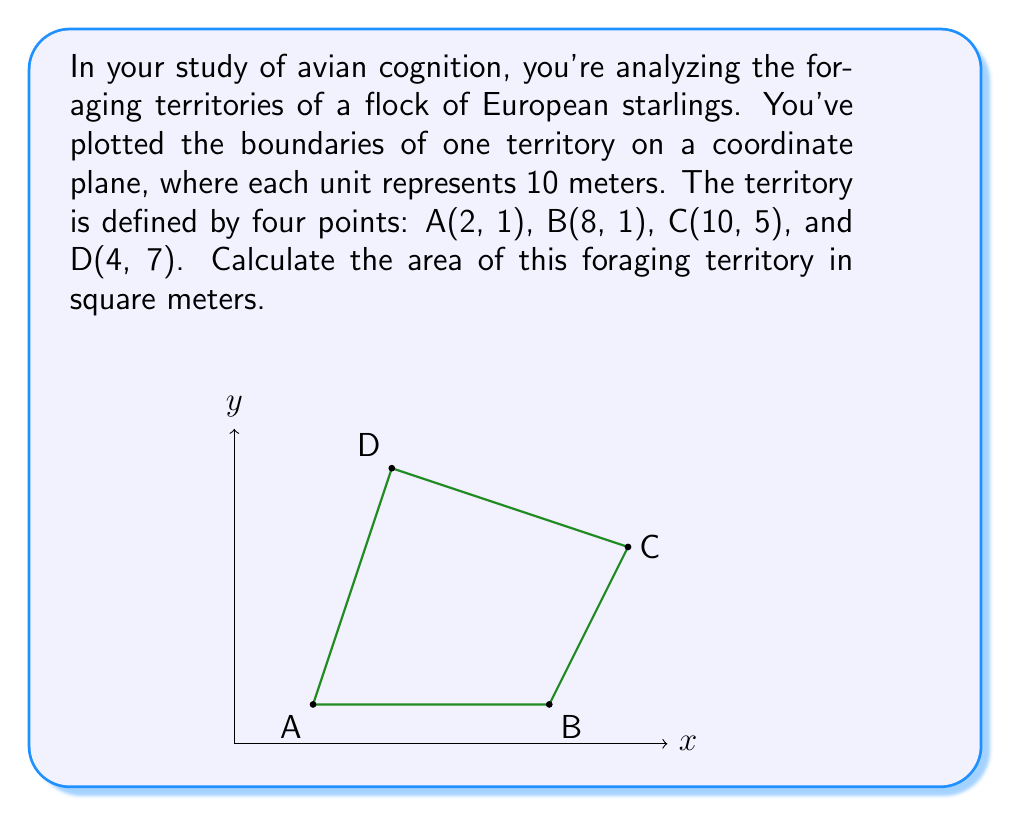Teach me how to tackle this problem. To solve this problem, we can use the shoelace formula (also known as the surveyor's formula) to calculate the area of the irregular polygon formed by the territory boundaries. The steps are as follows:

1) The shoelace formula for a quadrilateral with vertices $(x_1, y_1)$, $(x_2, y_2)$, $(x_3, y_3)$, and $(x_4, y_4)$ is:

   $$Area = \frac{1}{2}|(x_1y_2 + x_2y_3 + x_3y_4 + x_4y_1) - (y_1x_2 + y_2x_3 + y_3x_4 + y_4x_1)|$$

2) Substituting our coordinates:
   A(2, 1), B(8, 1), C(10, 5), D(4, 7)

   $$Area = \frac{1}{2}|(2 \cdot 1 + 8 \cdot 5 + 10 \cdot 7 + 4 \cdot 1) - (1 \cdot 8 + 1 \cdot 10 + 5 \cdot 4 + 7 \cdot 2)|$$

3) Simplifying:

   $$Area = \frac{1}{2}|(2 + 40 + 70 + 4) - (8 + 10 + 20 + 14)|$$
   $$Area = \frac{1}{2}|116 - 52|$$
   $$Area = \frac{1}{2} \cdot 64 = 32$$

4) This result is in square units on our coordinate plane. Since each unit represents 10 meters, we need to multiply by $10^2 = 100$ to get the area in square meters:

   $$32 \cdot 100 = 3200 \text{ square meters}$$

Thus, the foraging territory of this European starling covers an area of 3200 square meters.
Answer: 3200 square meters 